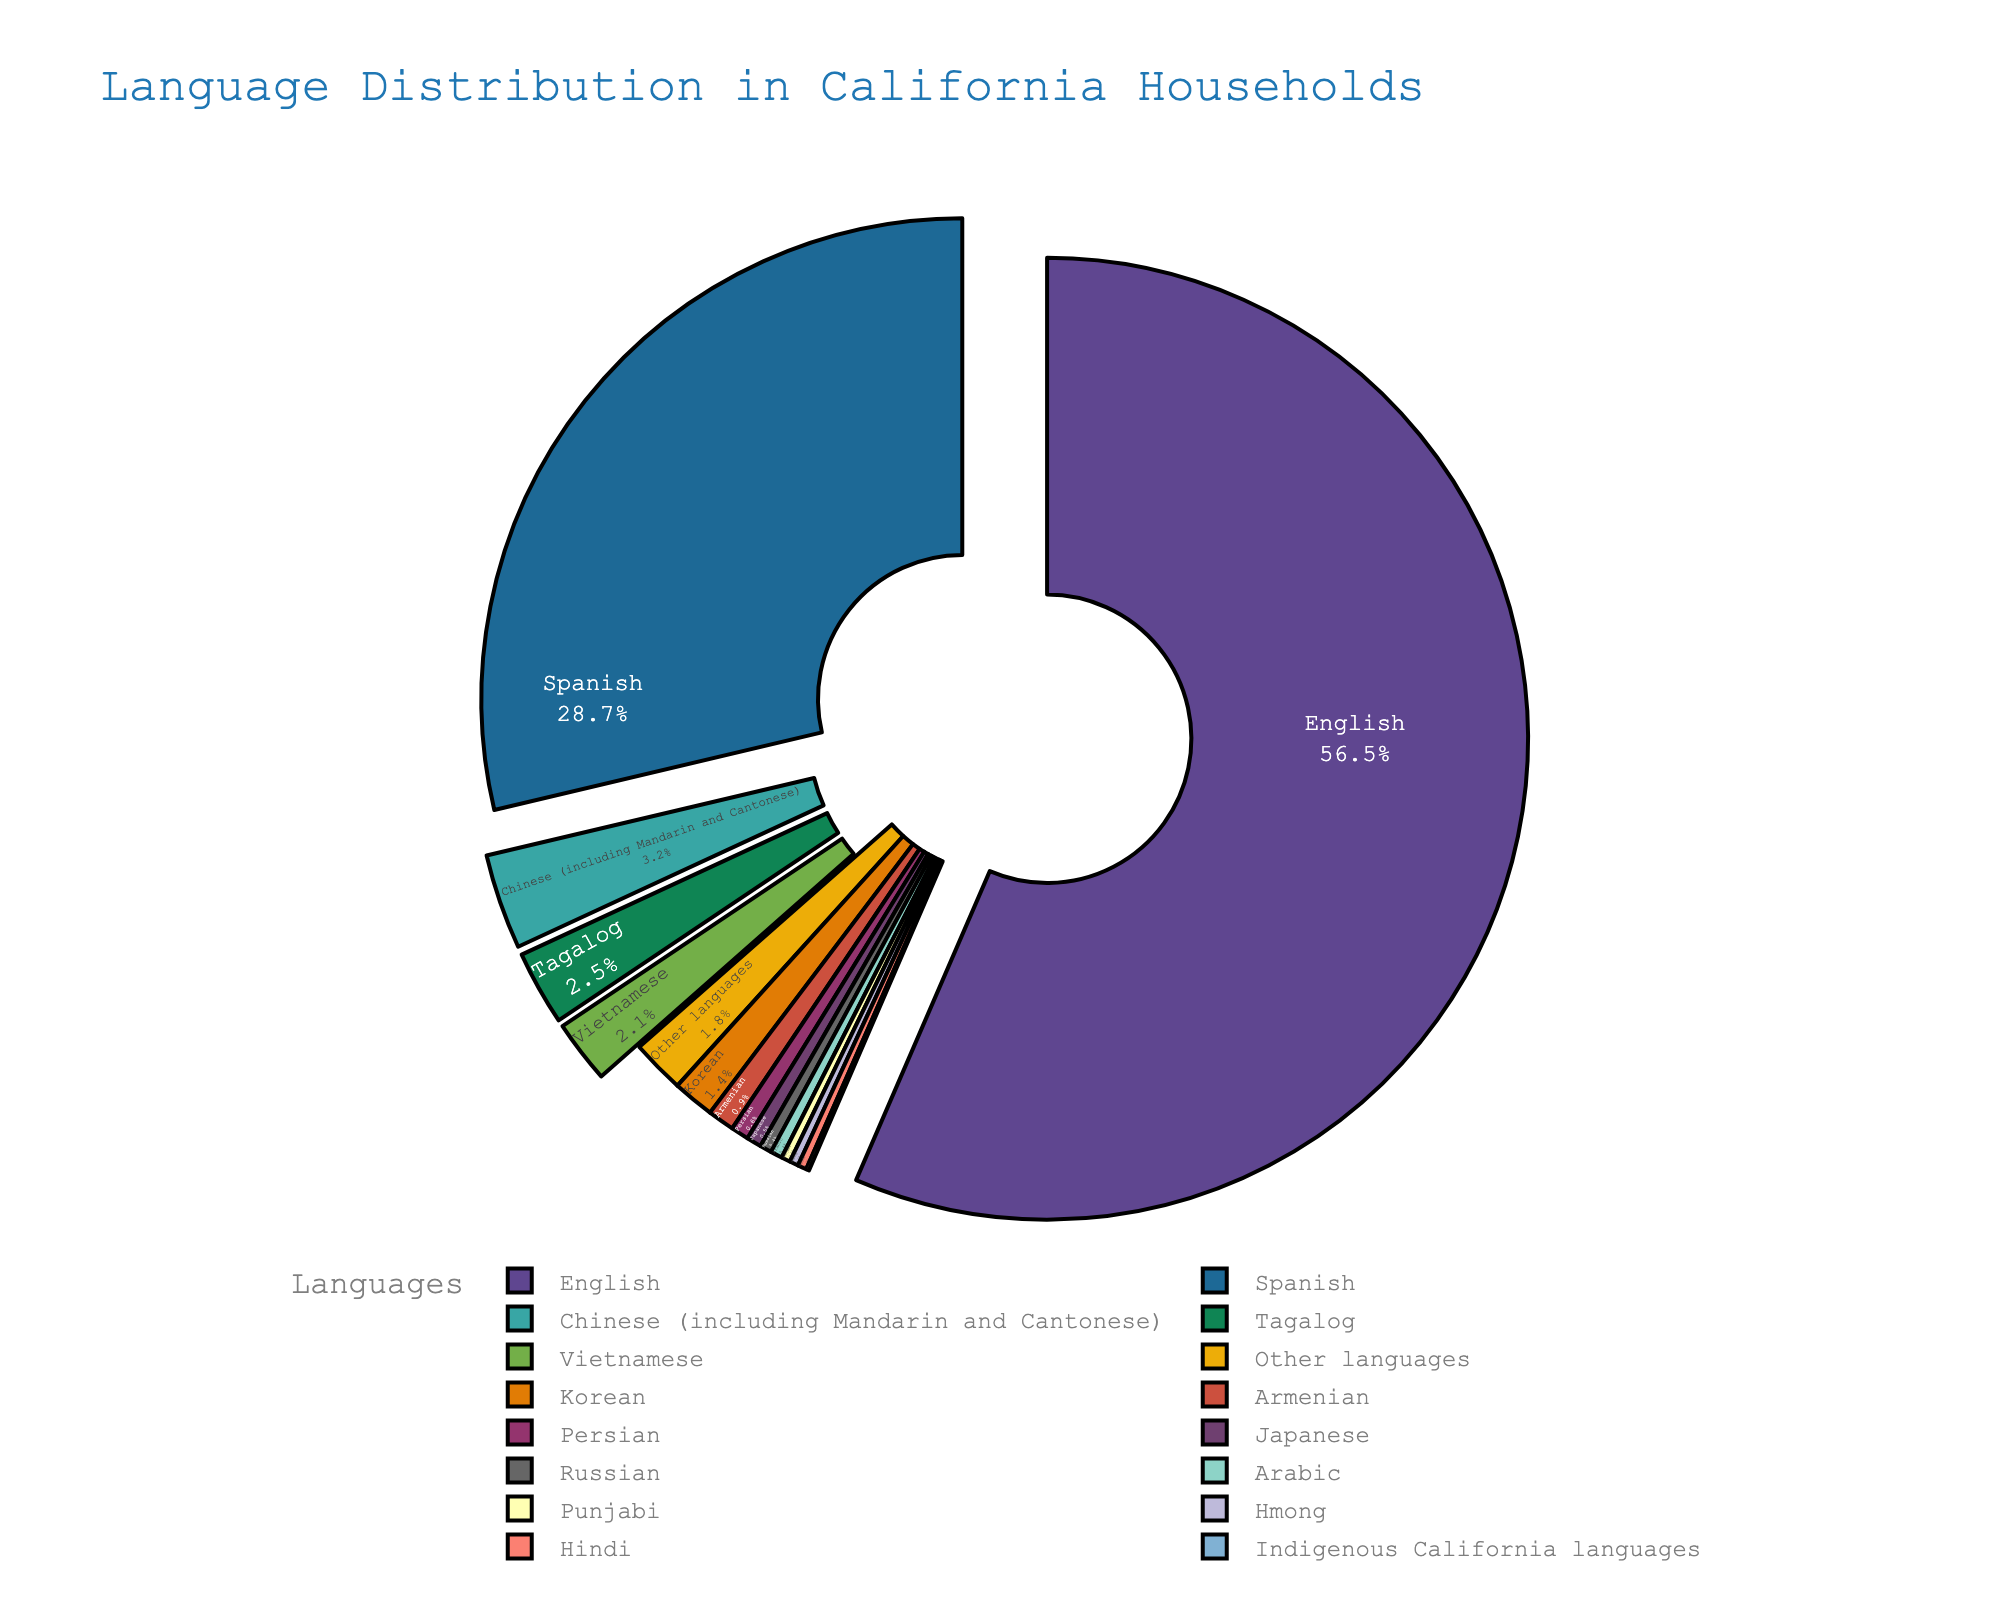What is the most common language spoken in California households? The largest section of the pie chart represents English, indicating that it is the most common language spoken.
Answer: English What is the combined percentage of households speaking Spanish and Chinese (including Mandarin and Cantonese)? According to the pie chart, the percentage of households speaking Spanish is 28.7% and those speaking Chinese (including Mandarin and Cantonese) is 3.2%. Adding these together gives 28.7% + 3.2% = 31.9%.
Answer: 31.9% Which language has a slightly higher percentage: Tagalog or Vietnamese? The pie chart shows that Tagalog is represented by 2.5% and Vietnamese by 2.1%, meaning Tagalog has a slightly higher percentage.
Answer: Tagalog What is the total percentage of households speaking Korean, Armenian, and Persian? The pie chart reveals the following percentages: Korean (1.4%), Armenian (0.9%), and Persian (0.6%). Adding them together results in 1.4% + 0.9% + 0.6% = 2.9%.
Answer: 2.9% Do more households speak Russian or Arabic in California? According to the pie chart, both Russian and Arabic each constitute 0.4% of households. Thus, both are spoken by an equal percentage.
Answer: Equal What is the difference in percentage between households speaking English and those speaking Spanish? The pie chart indicates 56.5% of households speak English and 28.7% speak Spanish. The difference is 56.5% - 28.7% = 27.8%.
Answer: 27.8% How many languages are spoken in less than 1% of California households? The pie chart lists several languages with percentages under 1%: Armenian (0.9%), Persian (0.6%), Japanese (0.5%), Russian (0.4%), Arabic (0.4%), Punjabi (0.3%), Hmong (0.3%), Hindi (0.3%), Indigenous California languages (0.1%), and Other languages (1.8%). In total, there are 8 languages spoken by less than 1% of households.
Answer: 8 If Tagalog, Vietnamese, and Korean were combined into a single category, what would be their total percentage? The pie chart indicates the following percentages: Tagalog (2.5%), Vietnamese (2.1%), and Korean (1.4%). Adding these together gives 2.5% + 2.1% + 1.4% = 6.0%.
Answer: 6.0% Is the percentage of households speaking English more than double that of those speaking Spanish? The pie chart indicates 56.5% of households speak English and 28.7% speak Spanish. Double the Spanish-speaking percentage is 28.7% * 2 = 57.4%. Since 56.5% (English) is slightly less than 57.4%, it is not more than double.
Answer: No Is there any language that holds precisely 0.5% of the household share? According to the pie chart, Japanese holds exactly 0.5% of the household share.
Answer: Japanese 